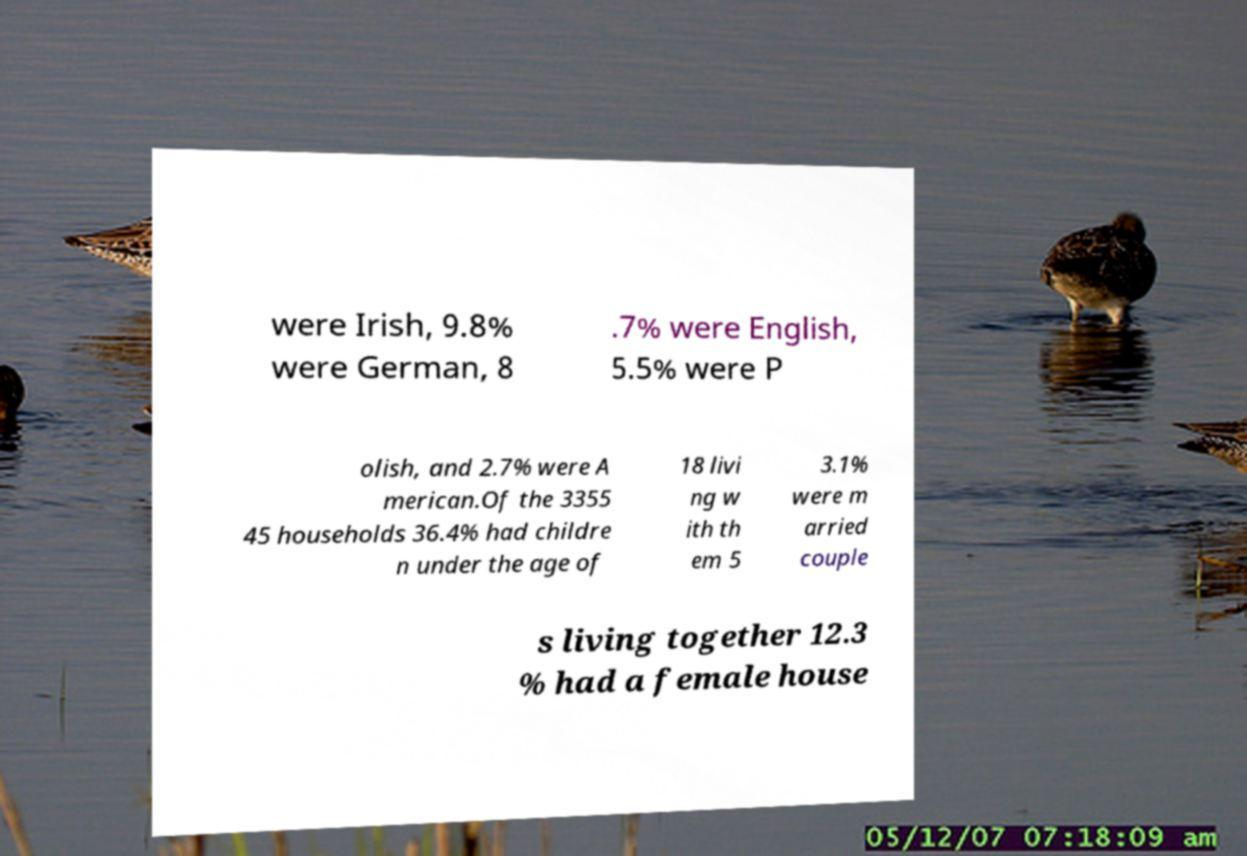Could you assist in decoding the text presented in this image and type it out clearly? were Irish, 9.8% were German, 8 .7% were English, 5.5% were P olish, and 2.7% were A merican.Of the 3355 45 households 36.4% had childre n under the age of 18 livi ng w ith th em 5 3.1% were m arried couple s living together 12.3 % had a female house 